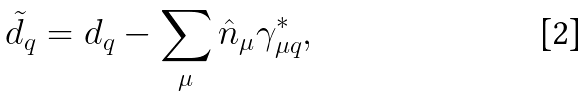Convert formula to latex. <formula><loc_0><loc_0><loc_500><loc_500>\tilde { d } _ { q } = d _ { q } - \sum _ { \mu } \hat { n } _ { \mu } \gamma _ { \mu q } ^ { \ast } ,</formula> 